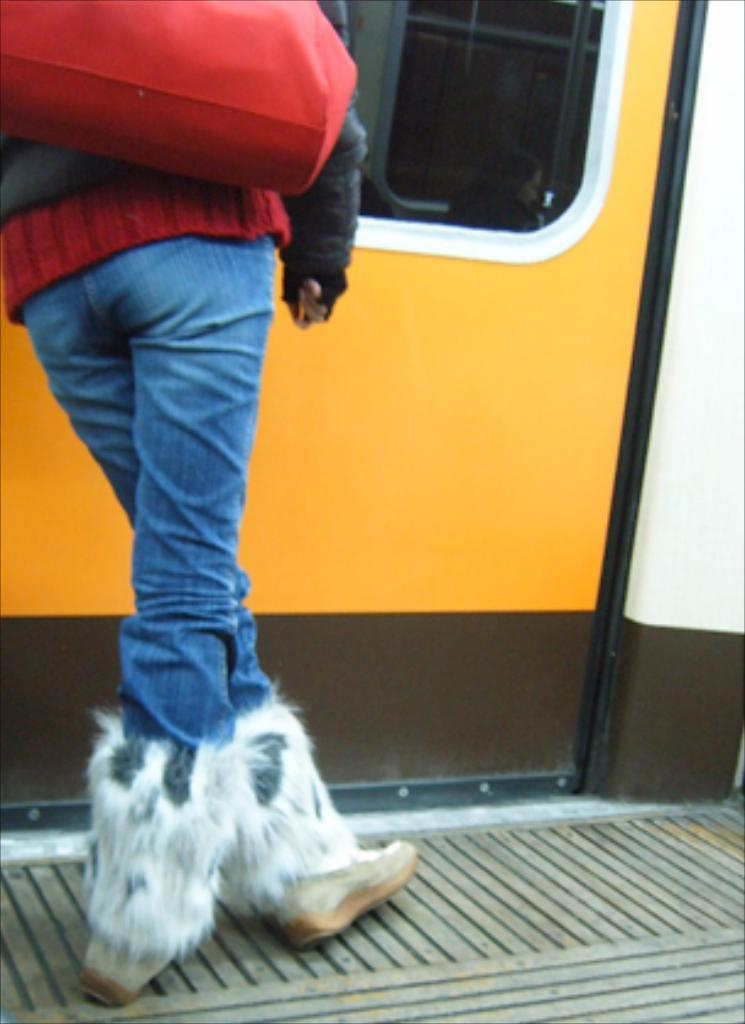What is the main subject of the image? There is a person in the image. What type of clothing is the person wearing? The person is wearing blue jeans and boots. Where is the person located in relation to the door? The person is standing near a door. What is the color of the door? The door is in yellow color. What type of spade is the person holding in the image? There is no spade present in the image; the person is wearing boots and standing near a yellow door. 